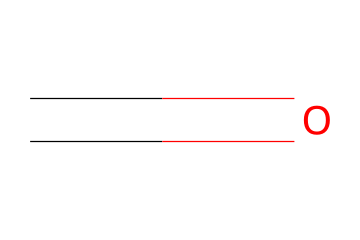What is the molecular formula of this chemical? The chemical structure provided involves one carbon atom and one oxygen atom, which together represent the molecular formula CH2O.
Answer: CH2O How many valence electrons are involved in the molecular structure? Carbon has 4 valence electrons and oxygen has 6, giving a total of 10 valence electrons (4 + 6).
Answer: 10 What type of bond exists between the carbon and the oxygen? The structure shows a double bond between carbon and oxygen, which is characteristic of carbonyl compounds.
Answer: double bond Is this chemical classified as an aldehyde or a ketone? The given structure has the carbonyl group (C=O) at the end of the carbon chain, indicating that it is classified as an aldehyde.
Answer: aldehyde What potential health effect is associated with this chemical? Formaldehyde is known to be a carcinogen, meaning it can cause cancer upon prolonged exposure.
Answer: carcinogen How does the presence of the carbonyl group impact the reactivity of this chemical? The carbonyl group makes formaldehyde highly reactive and capable of participating in various chemical reactions, including polymerization and condensation reactions.
Answer: highly reactive What is a common source of exposure to this chemical in everyday life? Formaldehyde is commonly found in many household products, including furniture and building materials, which can release it into the air.
Answer: household products 